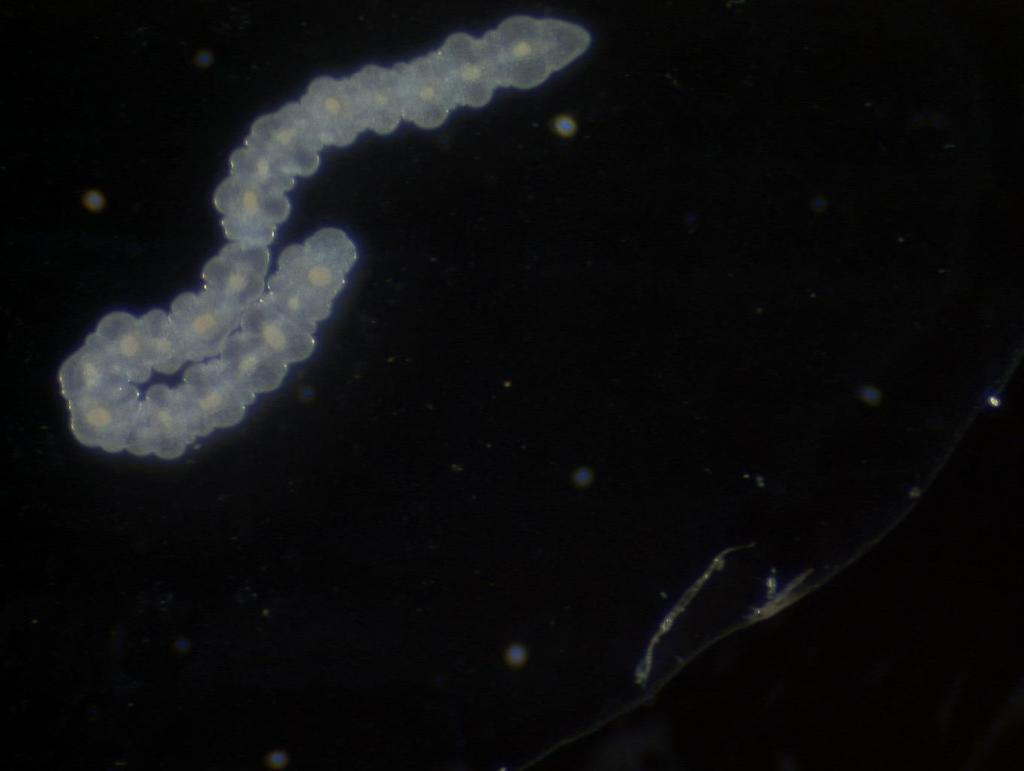What is the person in the picture doing with the dog? The person is walking the dog. How many ants are crawling on the bun in the image? There is no bun or ants present in the image; it features a person walking a dog. 